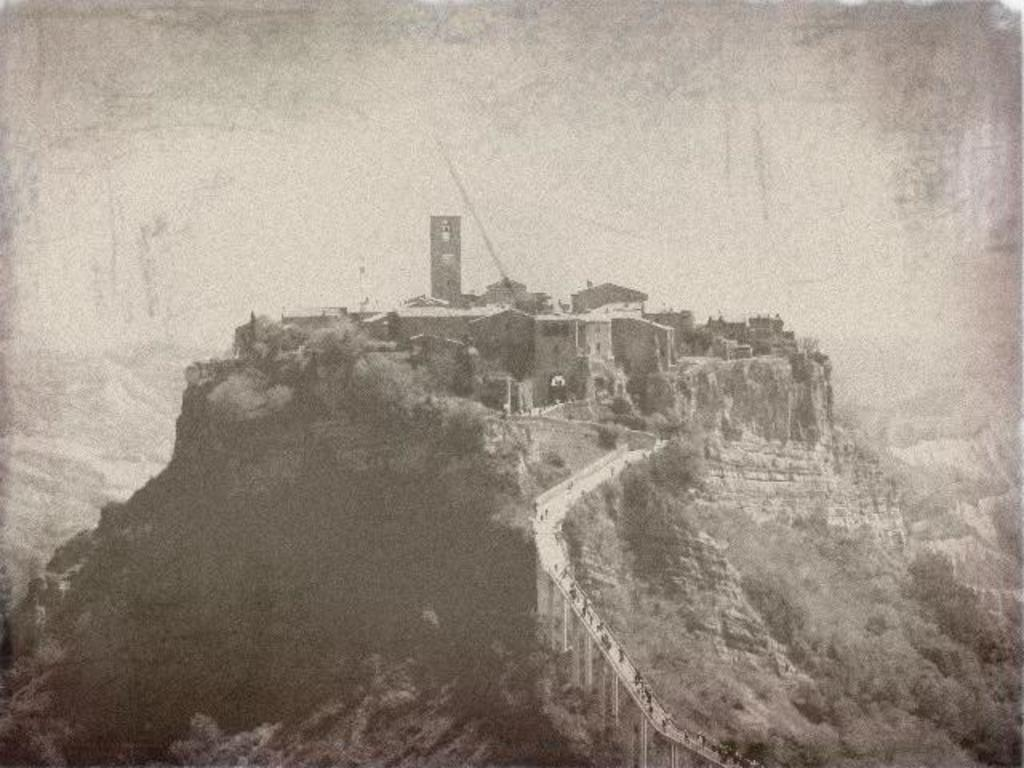What type of natural environment is depicted in the image? There are many trees and mountains in the image, indicating a natural environment. Can you describe the man-made structures in the image? There are people on a bridge and buildings in the background of the image. What is visible in the background of the image? The sky is visible in the background of the image. How many snails can be seen crawling on the bridge in the image? There are no snails visible on the bridge in the image. What type of screw is holding the bridge together in the image? There is no screw visible in the image, as it focuses on the people on the bridge rather than its construction. 